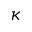Convert formula to latex. <formula><loc_0><loc_0><loc_500><loc_500>\kappa</formula> 